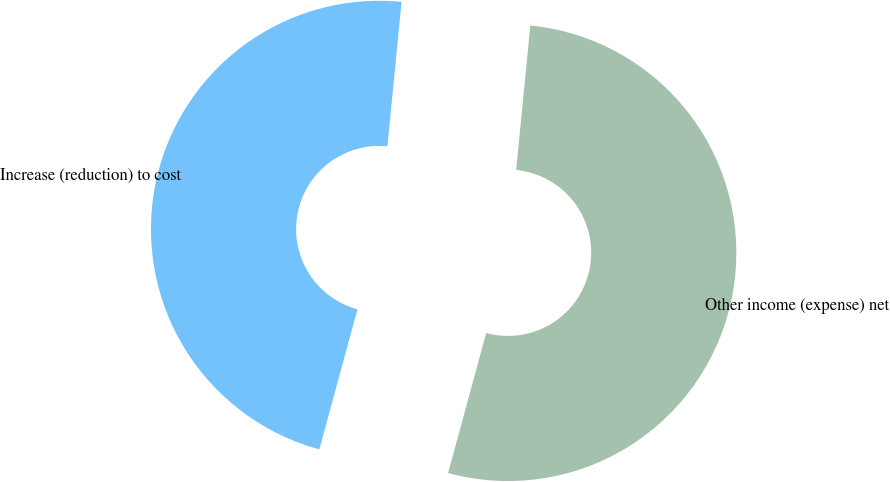Convert chart to OTSL. <chart><loc_0><loc_0><loc_500><loc_500><pie_chart><fcel>Increase (reduction) to cost<fcel>Other income (expense) net<nl><fcel>47.33%<fcel>52.67%<nl></chart> 